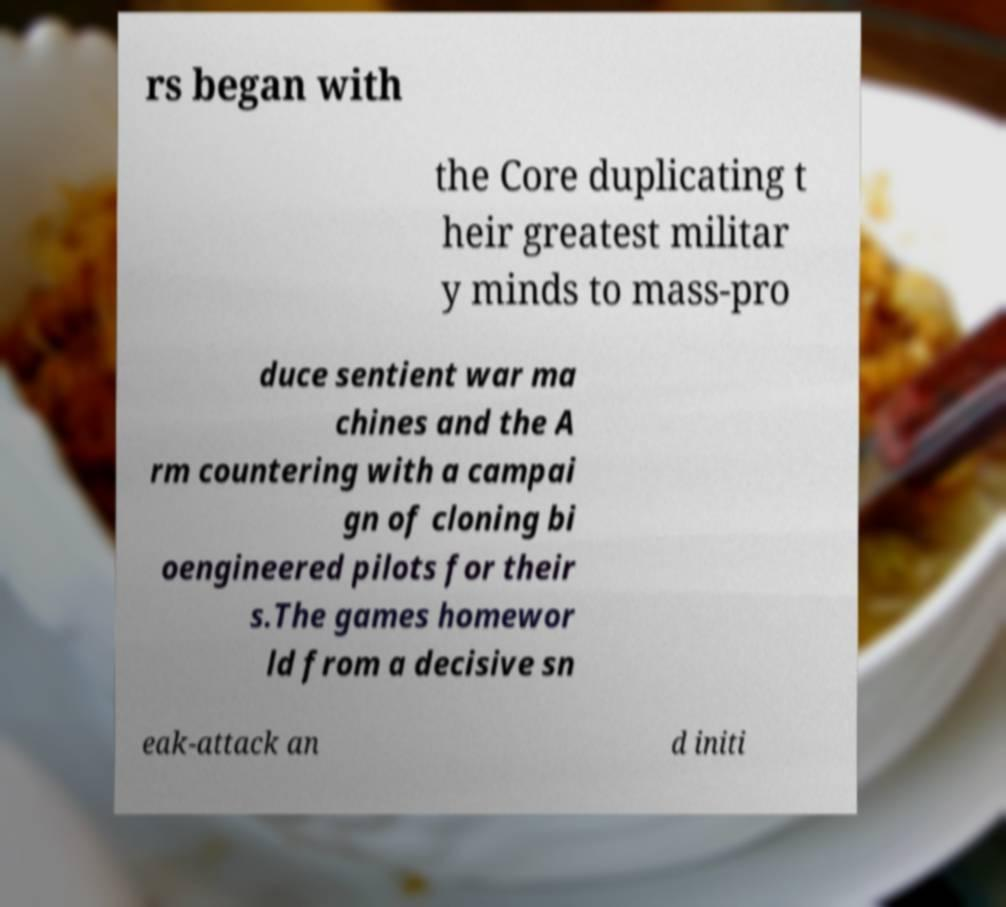For documentation purposes, I need the text within this image transcribed. Could you provide that? rs began with the Core duplicating t heir greatest militar y minds to mass-pro duce sentient war ma chines and the A rm countering with a campai gn of cloning bi oengineered pilots for their s.The games homewor ld from a decisive sn eak-attack an d initi 